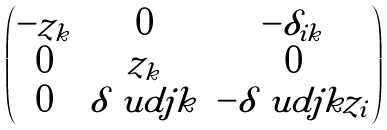<formula> <loc_0><loc_0><loc_500><loc_500>\begin{pmatrix} - z _ { k } & 0 & - \delta _ { i k } \\ 0 & z _ { k } & 0 \\ 0 & \delta \ u d { j } { k } & - \delta \ u d { j } { k } z _ { i } \end{pmatrix}</formula> 